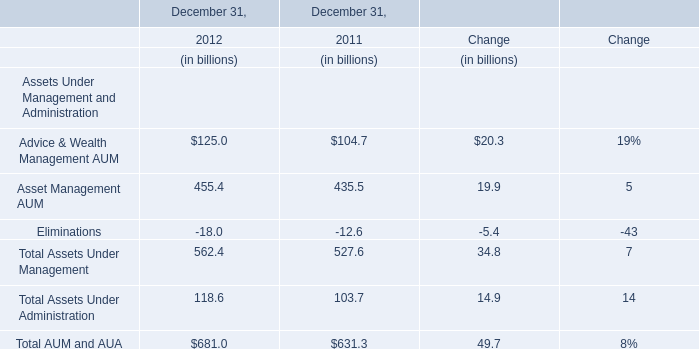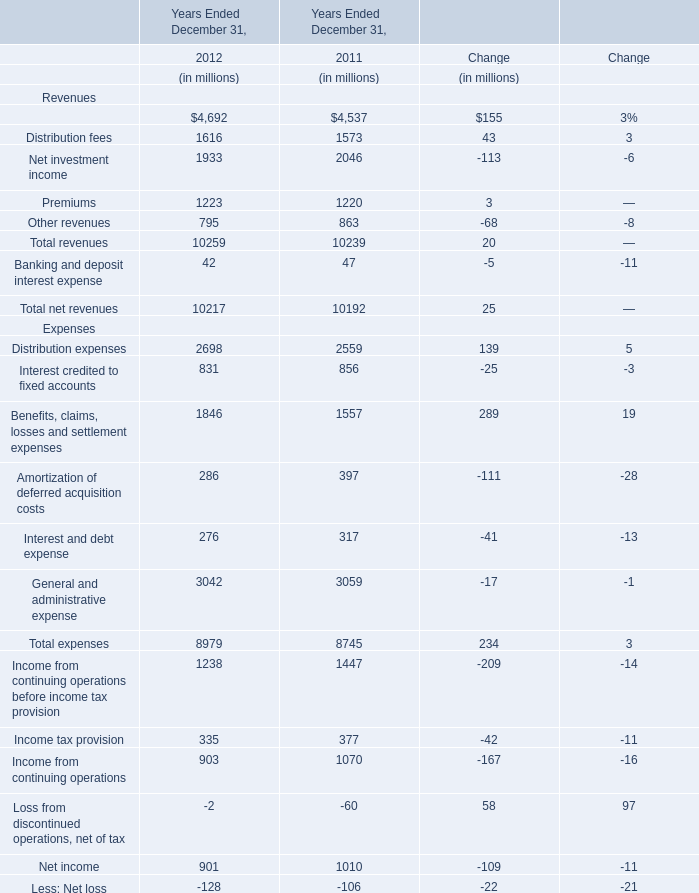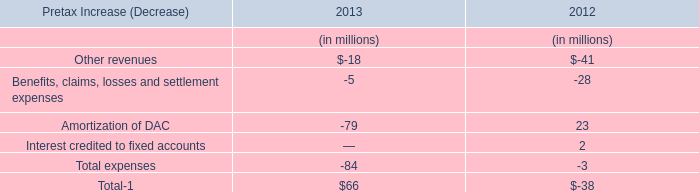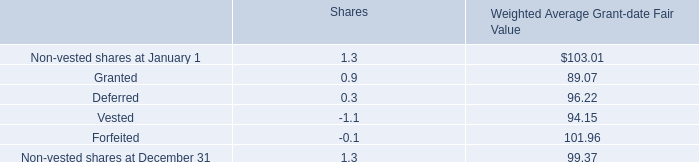What's the average of the Distribution fees in table 1 in the years where Distribution fees in table 1 is positive? (in millions) 
Computations: ((1616 + 1573) / 2)
Answer: 1594.5. 